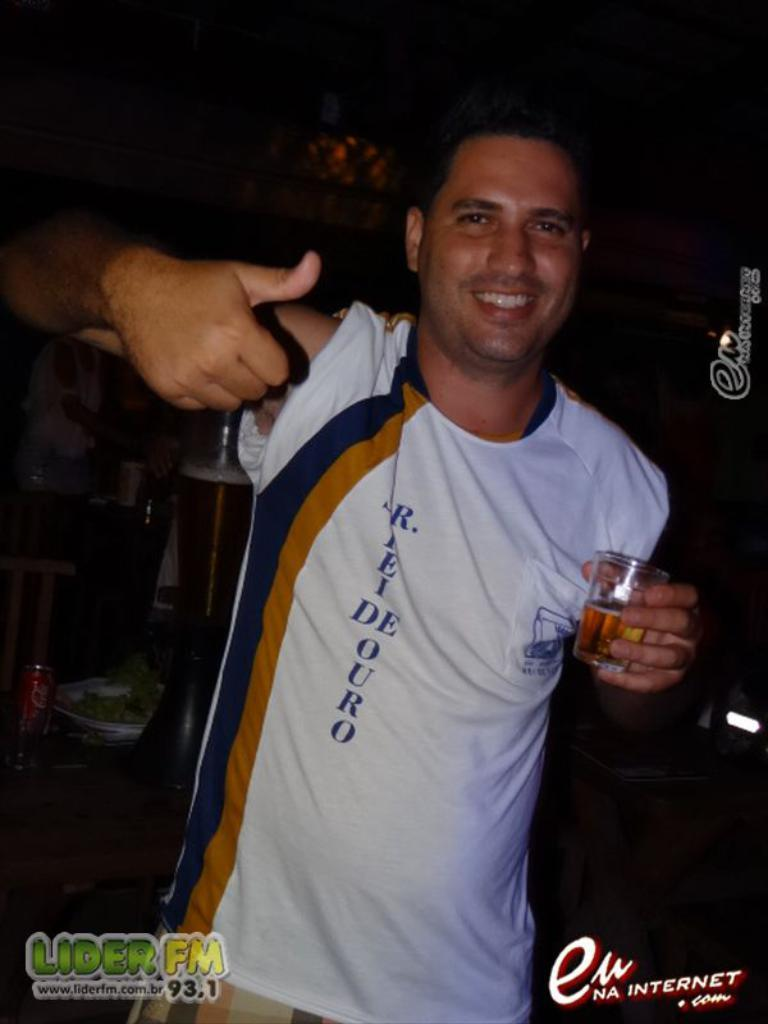What is the man in the image doing? The man is standing in the image. What is the man holding in his hand? The man is holding a glass in his hand. Can you describe the people in the background of the image? There is a group of people in the background of the image. What type of vein is visible on the man's forehead in the image? There is no visible vein on the man's forehead in the image. Are the police present in the image? There is no indication of the police being present in the image. Can you see any screws in the image? There are no screws visible in the image. 